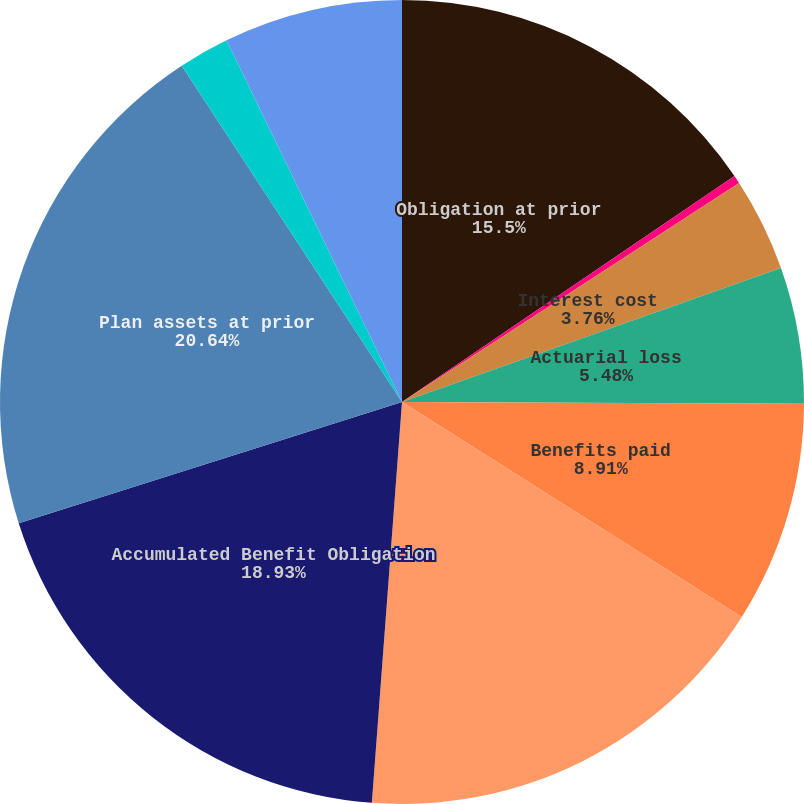Convert chart to OTSL. <chart><loc_0><loc_0><loc_500><loc_500><pie_chart><fcel>Obligation at prior<fcel>Service cost<fcel>Interest cost<fcel>Actuarial loss<fcel>Benefits paid<fcel>Obligation at measurement date<fcel>Accumulated Benefit Obligation<fcel>Plan assets at prior<fcel>Employer contributions<fcel>Actual return on plan assets<nl><fcel>15.5%<fcel>0.33%<fcel>3.76%<fcel>5.48%<fcel>8.91%<fcel>17.22%<fcel>18.93%<fcel>20.65%<fcel>2.04%<fcel>7.19%<nl></chart> 